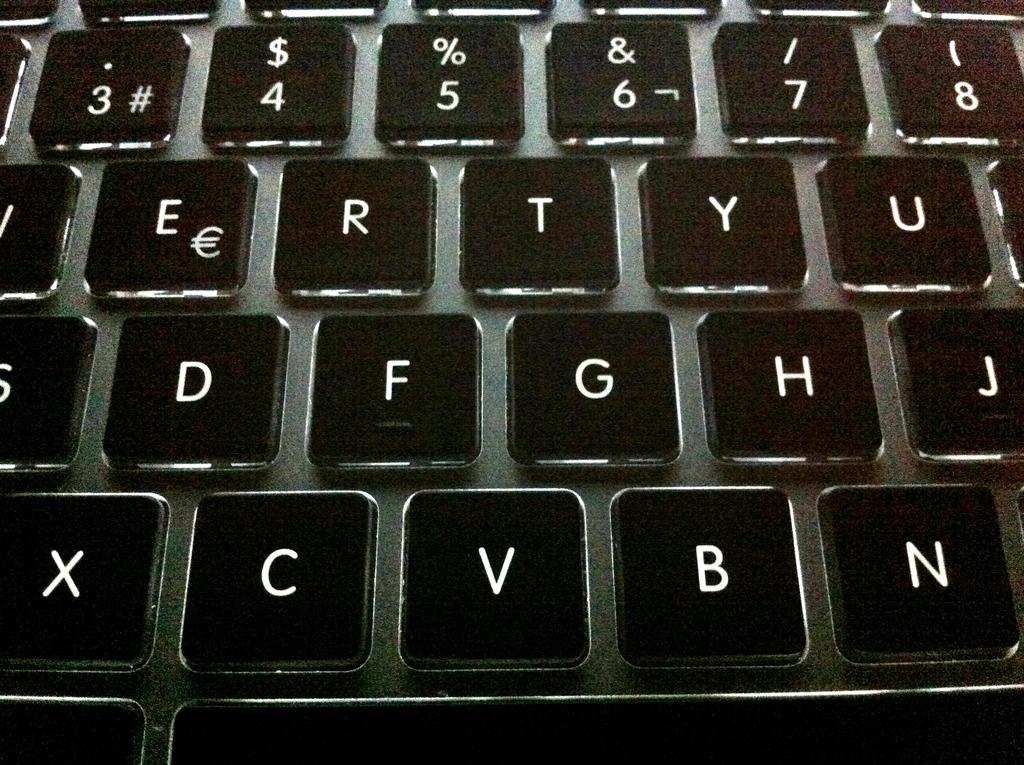<image>
Provide a brief description of the given image. Black and white keyboard with letters and numbers 